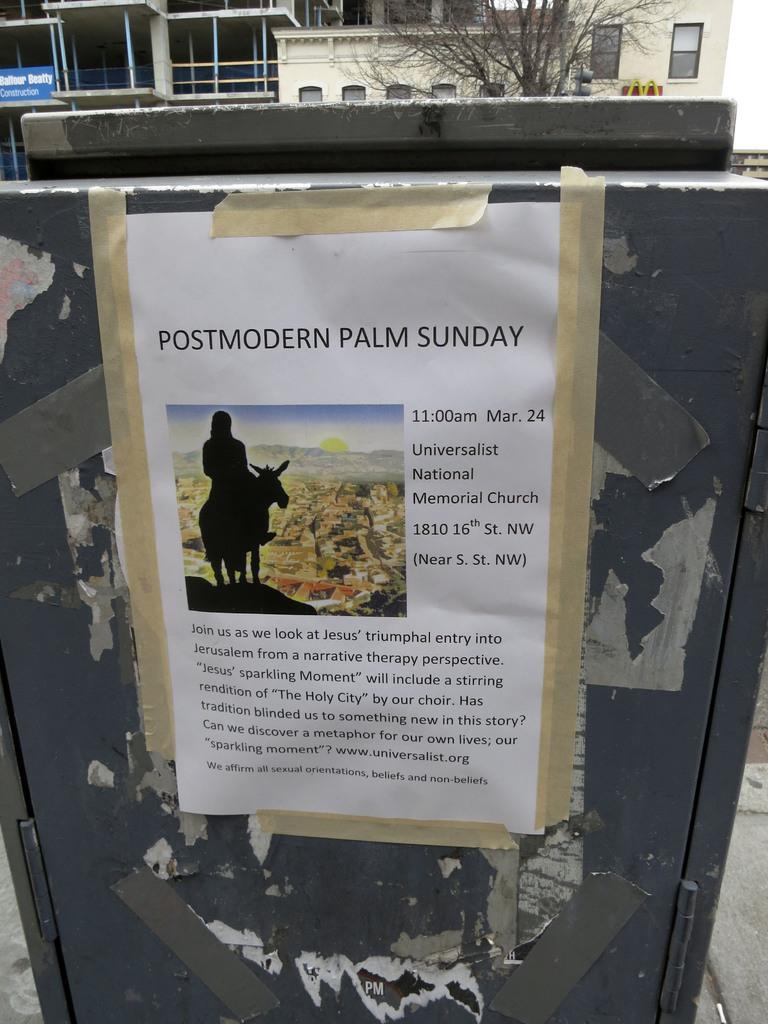Could you give a brief overview of what you see in this image? In this image, we can see a poster on the box. In this poster, we can see some text, image. Top of the image, there are few houses, hoarding, tree, glass windows, pillars, poles we can see. 